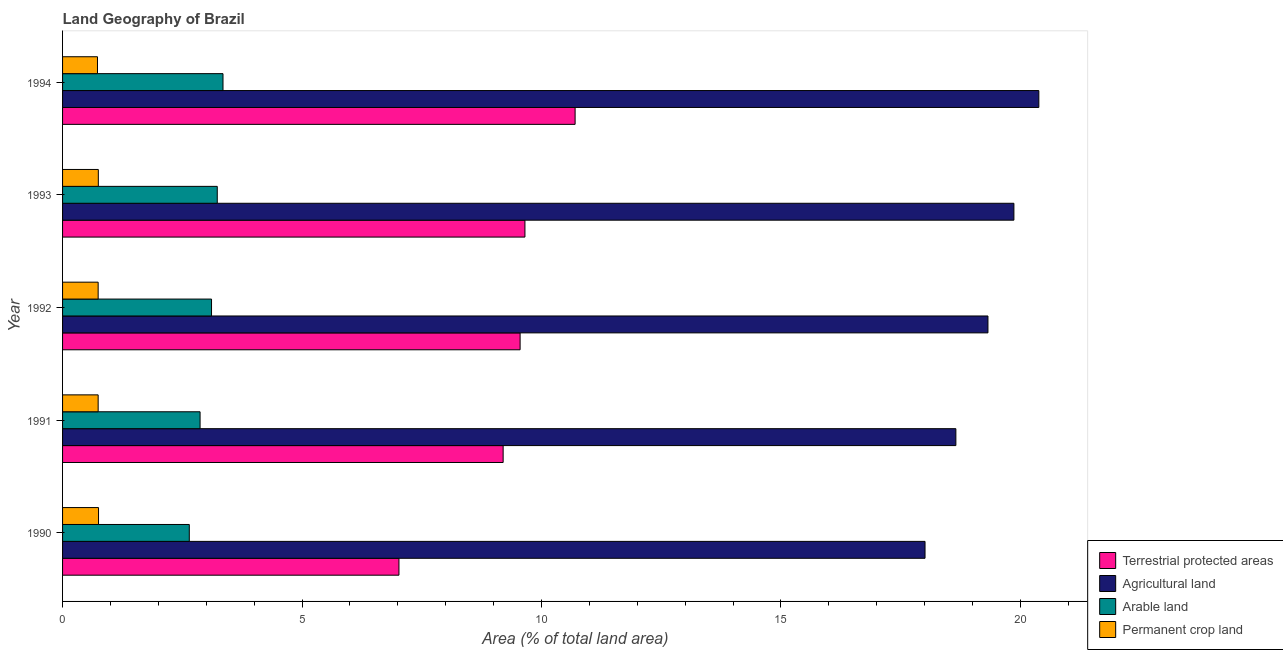Are the number of bars on each tick of the Y-axis equal?
Your response must be concise. Yes. How many bars are there on the 3rd tick from the top?
Your response must be concise. 4. In how many cases, is the number of bars for a given year not equal to the number of legend labels?
Keep it short and to the point. 0. What is the percentage of area under permanent crop land in 1991?
Provide a short and direct response. 0.74. Across all years, what is the maximum percentage of land under terrestrial protection?
Offer a very short reply. 10.7. Across all years, what is the minimum percentage of area under permanent crop land?
Your answer should be compact. 0.73. In which year was the percentage of area under arable land maximum?
Your response must be concise. 1994. What is the total percentage of area under agricultural land in the graph?
Your answer should be very brief. 96.24. What is the difference between the percentage of land under terrestrial protection in 1991 and that in 1993?
Your response must be concise. -0.46. What is the difference between the percentage of area under agricultural land in 1991 and the percentage of land under terrestrial protection in 1992?
Ensure brevity in your answer.  9.1. What is the average percentage of area under arable land per year?
Keep it short and to the point. 3.04. In the year 1990, what is the difference between the percentage of area under permanent crop land and percentage of land under terrestrial protection?
Give a very brief answer. -6.27. What is the ratio of the percentage of area under arable land in 1990 to that in 1991?
Your answer should be compact. 0.92. Is the percentage of area under permanent crop land in 1991 less than that in 1993?
Your answer should be compact. Yes. What is the difference between the highest and the second highest percentage of area under agricultural land?
Keep it short and to the point. 0.52. What is the difference between the highest and the lowest percentage of area under permanent crop land?
Your answer should be very brief. 0.02. In how many years, is the percentage of area under arable land greater than the average percentage of area under arable land taken over all years?
Provide a short and direct response. 3. Is the sum of the percentage of area under agricultural land in 1991 and 1992 greater than the maximum percentage of area under permanent crop land across all years?
Your answer should be compact. Yes. Is it the case that in every year, the sum of the percentage of area under permanent crop land and percentage of area under agricultural land is greater than the sum of percentage of area under arable land and percentage of land under terrestrial protection?
Your response must be concise. Yes. What does the 1st bar from the top in 1994 represents?
Provide a short and direct response. Permanent crop land. What does the 4th bar from the bottom in 1993 represents?
Your answer should be very brief. Permanent crop land. How many bars are there?
Offer a terse response. 20. Are all the bars in the graph horizontal?
Your answer should be very brief. Yes. How many years are there in the graph?
Offer a terse response. 5. Where does the legend appear in the graph?
Give a very brief answer. Bottom right. How many legend labels are there?
Offer a very short reply. 4. What is the title of the graph?
Ensure brevity in your answer.  Land Geography of Brazil. What is the label or title of the X-axis?
Ensure brevity in your answer.  Area (% of total land area). What is the label or title of the Y-axis?
Your answer should be compact. Year. What is the Area (% of total land area) of Terrestrial protected areas in 1990?
Give a very brief answer. 7.02. What is the Area (% of total land area) of Agricultural land in 1990?
Provide a succinct answer. 18.01. What is the Area (% of total land area) of Arable land in 1990?
Your response must be concise. 2.65. What is the Area (% of total land area) of Permanent crop land in 1990?
Make the answer very short. 0.75. What is the Area (% of total land area) in Terrestrial protected areas in 1991?
Offer a very short reply. 9.2. What is the Area (% of total land area) of Agricultural land in 1991?
Offer a terse response. 18.65. What is the Area (% of total land area) of Arable land in 1991?
Offer a very short reply. 2.87. What is the Area (% of total land area) of Permanent crop land in 1991?
Ensure brevity in your answer.  0.74. What is the Area (% of total land area) in Terrestrial protected areas in 1992?
Give a very brief answer. 9.55. What is the Area (% of total land area) in Agricultural land in 1992?
Your answer should be very brief. 19.32. What is the Area (% of total land area) of Arable land in 1992?
Give a very brief answer. 3.11. What is the Area (% of total land area) in Permanent crop land in 1992?
Offer a terse response. 0.74. What is the Area (% of total land area) in Terrestrial protected areas in 1993?
Your answer should be very brief. 9.66. What is the Area (% of total land area) in Agricultural land in 1993?
Offer a very short reply. 19.87. What is the Area (% of total land area) in Arable land in 1993?
Ensure brevity in your answer.  3.23. What is the Area (% of total land area) in Permanent crop land in 1993?
Make the answer very short. 0.75. What is the Area (% of total land area) in Terrestrial protected areas in 1994?
Your answer should be very brief. 10.7. What is the Area (% of total land area) of Agricultural land in 1994?
Your answer should be very brief. 20.39. What is the Area (% of total land area) in Arable land in 1994?
Offer a very short reply. 3.35. What is the Area (% of total land area) in Permanent crop land in 1994?
Your answer should be compact. 0.73. Across all years, what is the maximum Area (% of total land area) of Terrestrial protected areas?
Your answer should be very brief. 10.7. Across all years, what is the maximum Area (% of total land area) of Agricultural land?
Offer a very short reply. 20.39. Across all years, what is the maximum Area (% of total land area) of Arable land?
Make the answer very short. 3.35. Across all years, what is the maximum Area (% of total land area) in Permanent crop land?
Your response must be concise. 0.75. Across all years, what is the minimum Area (% of total land area) in Terrestrial protected areas?
Keep it short and to the point. 7.02. Across all years, what is the minimum Area (% of total land area) in Agricultural land?
Keep it short and to the point. 18.01. Across all years, what is the minimum Area (% of total land area) of Arable land?
Your answer should be compact. 2.65. Across all years, what is the minimum Area (% of total land area) of Permanent crop land?
Provide a succinct answer. 0.73. What is the total Area (% of total land area) in Terrestrial protected areas in the graph?
Ensure brevity in your answer.  46.14. What is the total Area (% of total land area) of Agricultural land in the graph?
Provide a short and direct response. 96.24. What is the total Area (% of total land area) of Arable land in the graph?
Ensure brevity in your answer.  15.21. What is the total Area (% of total land area) in Permanent crop land in the graph?
Your response must be concise. 3.71. What is the difference between the Area (% of total land area) of Terrestrial protected areas in 1990 and that in 1991?
Make the answer very short. -2.18. What is the difference between the Area (% of total land area) of Agricultural land in 1990 and that in 1991?
Your answer should be compact. -0.64. What is the difference between the Area (% of total land area) of Arable land in 1990 and that in 1991?
Your answer should be very brief. -0.23. What is the difference between the Area (% of total land area) of Permanent crop land in 1990 and that in 1991?
Your answer should be very brief. 0.01. What is the difference between the Area (% of total land area) of Terrestrial protected areas in 1990 and that in 1992?
Give a very brief answer. -2.53. What is the difference between the Area (% of total land area) of Agricultural land in 1990 and that in 1992?
Make the answer very short. -1.31. What is the difference between the Area (% of total land area) of Arable land in 1990 and that in 1992?
Offer a terse response. -0.46. What is the difference between the Area (% of total land area) of Permanent crop land in 1990 and that in 1992?
Provide a succinct answer. 0.01. What is the difference between the Area (% of total land area) of Terrestrial protected areas in 1990 and that in 1993?
Keep it short and to the point. -2.63. What is the difference between the Area (% of total land area) in Agricultural land in 1990 and that in 1993?
Offer a very short reply. -1.86. What is the difference between the Area (% of total land area) of Arable land in 1990 and that in 1993?
Provide a succinct answer. -0.58. What is the difference between the Area (% of total land area) of Permanent crop land in 1990 and that in 1993?
Your response must be concise. 0. What is the difference between the Area (% of total land area) of Terrestrial protected areas in 1990 and that in 1994?
Ensure brevity in your answer.  -3.68. What is the difference between the Area (% of total land area) of Agricultural land in 1990 and that in 1994?
Your answer should be very brief. -2.38. What is the difference between the Area (% of total land area) of Arable land in 1990 and that in 1994?
Ensure brevity in your answer.  -0.7. What is the difference between the Area (% of total land area) in Permanent crop land in 1990 and that in 1994?
Your answer should be very brief. 0.02. What is the difference between the Area (% of total land area) of Terrestrial protected areas in 1991 and that in 1992?
Your answer should be very brief. -0.35. What is the difference between the Area (% of total land area) of Agricultural land in 1991 and that in 1992?
Your answer should be very brief. -0.67. What is the difference between the Area (% of total land area) of Arable land in 1991 and that in 1992?
Your answer should be compact. -0.24. What is the difference between the Area (% of total land area) of Terrestrial protected areas in 1991 and that in 1993?
Keep it short and to the point. -0.46. What is the difference between the Area (% of total land area) in Agricultural land in 1991 and that in 1993?
Offer a terse response. -1.21. What is the difference between the Area (% of total land area) in Arable land in 1991 and that in 1993?
Make the answer very short. -0.36. What is the difference between the Area (% of total land area) in Permanent crop land in 1991 and that in 1993?
Your response must be concise. -0. What is the difference between the Area (% of total land area) of Terrestrial protected areas in 1991 and that in 1994?
Offer a very short reply. -1.5. What is the difference between the Area (% of total land area) of Agricultural land in 1991 and that in 1994?
Your answer should be very brief. -1.73. What is the difference between the Area (% of total land area) of Arable land in 1991 and that in 1994?
Your answer should be compact. -0.48. What is the difference between the Area (% of total land area) in Permanent crop land in 1991 and that in 1994?
Keep it short and to the point. 0.01. What is the difference between the Area (% of total land area) in Terrestrial protected areas in 1992 and that in 1993?
Give a very brief answer. -0.1. What is the difference between the Area (% of total land area) of Agricultural land in 1992 and that in 1993?
Ensure brevity in your answer.  -0.54. What is the difference between the Area (% of total land area) in Arable land in 1992 and that in 1993?
Provide a short and direct response. -0.12. What is the difference between the Area (% of total land area) in Permanent crop land in 1992 and that in 1993?
Your response must be concise. -0. What is the difference between the Area (% of total land area) in Terrestrial protected areas in 1992 and that in 1994?
Provide a succinct answer. -1.15. What is the difference between the Area (% of total land area) of Agricultural land in 1992 and that in 1994?
Offer a very short reply. -1.06. What is the difference between the Area (% of total land area) of Arable land in 1992 and that in 1994?
Your answer should be compact. -0.24. What is the difference between the Area (% of total land area) in Permanent crop land in 1992 and that in 1994?
Your answer should be compact. 0.01. What is the difference between the Area (% of total land area) of Terrestrial protected areas in 1993 and that in 1994?
Offer a very short reply. -1.05. What is the difference between the Area (% of total land area) in Agricultural land in 1993 and that in 1994?
Your answer should be compact. -0.52. What is the difference between the Area (% of total land area) of Arable land in 1993 and that in 1994?
Ensure brevity in your answer.  -0.12. What is the difference between the Area (% of total land area) in Permanent crop land in 1993 and that in 1994?
Offer a terse response. 0.02. What is the difference between the Area (% of total land area) of Terrestrial protected areas in 1990 and the Area (% of total land area) of Agricultural land in 1991?
Provide a short and direct response. -11.63. What is the difference between the Area (% of total land area) of Terrestrial protected areas in 1990 and the Area (% of total land area) of Arable land in 1991?
Your answer should be compact. 4.15. What is the difference between the Area (% of total land area) of Terrestrial protected areas in 1990 and the Area (% of total land area) of Permanent crop land in 1991?
Your response must be concise. 6.28. What is the difference between the Area (% of total land area) of Agricultural land in 1990 and the Area (% of total land area) of Arable land in 1991?
Your answer should be very brief. 15.14. What is the difference between the Area (% of total land area) of Agricultural land in 1990 and the Area (% of total land area) of Permanent crop land in 1991?
Provide a short and direct response. 17.27. What is the difference between the Area (% of total land area) in Arable land in 1990 and the Area (% of total land area) in Permanent crop land in 1991?
Ensure brevity in your answer.  1.9. What is the difference between the Area (% of total land area) in Terrestrial protected areas in 1990 and the Area (% of total land area) in Agricultural land in 1992?
Offer a very short reply. -12.3. What is the difference between the Area (% of total land area) of Terrestrial protected areas in 1990 and the Area (% of total land area) of Arable land in 1992?
Offer a very short reply. 3.91. What is the difference between the Area (% of total land area) in Terrestrial protected areas in 1990 and the Area (% of total land area) in Permanent crop land in 1992?
Your response must be concise. 6.28. What is the difference between the Area (% of total land area) in Agricultural land in 1990 and the Area (% of total land area) in Arable land in 1992?
Provide a succinct answer. 14.9. What is the difference between the Area (% of total land area) of Agricultural land in 1990 and the Area (% of total land area) of Permanent crop land in 1992?
Offer a very short reply. 17.27. What is the difference between the Area (% of total land area) of Arable land in 1990 and the Area (% of total land area) of Permanent crop land in 1992?
Offer a terse response. 1.9. What is the difference between the Area (% of total land area) in Terrestrial protected areas in 1990 and the Area (% of total land area) in Agricultural land in 1993?
Your answer should be compact. -12.84. What is the difference between the Area (% of total land area) of Terrestrial protected areas in 1990 and the Area (% of total land area) of Arable land in 1993?
Make the answer very short. 3.79. What is the difference between the Area (% of total land area) in Terrestrial protected areas in 1990 and the Area (% of total land area) in Permanent crop land in 1993?
Give a very brief answer. 6.28. What is the difference between the Area (% of total land area) in Agricultural land in 1990 and the Area (% of total land area) in Arable land in 1993?
Give a very brief answer. 14.78. What is the difference between the Area (% of total land area) of Agricultural land in 1990 and the Area (% of total land area) of Permanent crop land in 1993?
Your answer should be very brief. 17.26. What is the difference between the Area (% of total land area) in Arable land in 1990 and the Area (% of total land area) in Permanent crop land in 1993?
Your answer should be very brief. 1.9. What is the difference between the Area (% of total land area) of Terrestrial protected areas in 1990 and the Area (% of total land area) of Agricultural land in 1994?
Provide a short and direct response. -13.36. What is the difference between the Area (% of total land area) of Terrestrial protected areas in 1990 and the Area (% of total land area) of Arable land in 1994?
Provide a short and direct response. 3.67. What is the difference between the Area (% of total land area) of Terrestrial protected areas in 1990 and the Area (% of total land area) of Permanent crop land in 1994?
Provide a succinct answer. 6.3. What is the difference between the Area (% of total land area) in Agricultural land in 1990 and the Area (% of total land area) in Arable land in 1994?
Offer a very short reply. 14.66. What is the difference between the Area (% of total land area) in Agricultural land in 1990 and the Area (% of total land area) in Permanent crop land in 1994?
Provide a succinct answer. 17.28. What is the difference between the Area (% of total land area) in Arable land in 1990 and the Area (% of total land area) in Permanent crop land in 1994?
Ensure brevity in your answer.  1.92. What is the difference between the Area (% of total land area) of Terrestrial protected areas in 1991 and the Area (% of total land area) of Agricultural land in 1992?
Your answer should be compact. -10.12. What is the difference between the Area (% of total land area) in Terrestrial protected areas in 1991 and the Area (% of total land area) in Arable land in 1992?
Your answer should be very brief. 6.09. What is the difference between the Area (% of total land area) of Terrestrial protected areas in 1991 and the Area (% of total land area) of Permanent crop land in 1992?
Keep it short and to the point. 8.46. What is the difference between the Area (% of total land area) in Agricultural land in 1991 and the Area (% of total land area) in Arable land in 1992?
Offer a terse response. 15.54. What is the difference between the Area (% of total land area) in Agricultural land in 1991 and the Area (% of total land area) in Permanent crop land in 1992?
Make the answer very short. 17.91. What is the difference between the Area (% of total land area) in Arable land in 1991 and the Area (% of total land area) in Permanent crop land in 1992?
Your response must be concise. 2.13. What is the difference between the Area (% of total land area) in Terrestrial protected areas in 1991 and the Area (% of total land area) in Agricultural land in 1993?
Give a very brief answer. -10.67. What is the difference between the Area (% of total land area) of Terrestrial protected areas in 1991 and the Area (% of total land area) of Arable land in 1993?
Your answer should be compact. 5.97. What is the difference between the Area (% of total land area) in Terrestrial protected areas in 1991 and the Area (% of total land area) in Permanent crop land in 1993?
Give a very brief answer. 8.45. What is the difference between the Area (% of total land area) of Agricultural land in 1991 and the Area (% of total land area) of Arable land in 1993?
Provide a short and direct response. 15.42. What is the difference between the Area (% of total land area) in Agricultural land in 1991 and the Area (% of total land area) in Permanent crop land in 1993?
Provide a short and direct response. 17.91. What is the difference between the Area (% of total land area) of Arable land in 1991 and the Area (% of total land area) of Permanent crop land in 1993?
Keep it short and to the point. 2.12. What is the difference between the Area (% of total land area) of Terrestrial protected areas in 1991 and the Area (% of total land area) of Agricultural land in 1994?
Keep it short and to the point. -11.19. What is the difference between the Area (% of total land area) of Terrestrial protected areas in 1991 and the Area (% of total land area) of Arable land in 1994?
Your answer should be compact. 5.85. What is the difference between the Area (% of total land area) of Terrestrial protected areas in 1991 and the Area (% of total land area) of Permanent crop land in 1994?
Your response must be concise. 8.47. What is the difference between the Area (% of total land area) in Agricultural land in 1991 and the Area (% of total land area) in Arable land in 1994?
Your answer should be very brief. 15.3. What is the difference between the Area (% of total land area) in Agricultural land in 1991 and the Area (% of total land area) in Permanent crop land in 1994?
Your response must be concise. 17.92. What is the difference between the Area (% of total land area) of Arable land in 1991 and the Area (% of total land area) of Permanent crop land in 1994?
Keep it short and to the point. 2.14. What is the difference between the Area (% of total land area) in Terrestrial protected areas in 1992 and the Area (% of total land area) in Agricultural land in 1993?
Offer a terse response. -10.31. What is the difference between the Area (% of total land area) in Terrestrial protected areas in 1992 and the Area (% of total land area) in Arable land in 1993?
Your response must be concise. 6.32. What is the difference between the Area (% of total land area) of Terrestrial protected areas in 1992 and the Area (% of total land area) of Permanent crop land in 1993?
Make the answer very short. 8.81. What is the difference between the Area (% of total land area) in Agricultural land in 1992 and the Area (% of total land area) in Arable land in 1993?
Your response must be concise. 16.09. What is the difference between the Area (% of total land area) of Agricultural land in 1992 and the Area (% of total land area) of Permanent crop land in 1993?
Offer a very short reply. 18.58. What is the difference between the Area (% of total land area) in Arable land in 1992 and the Area (% of total land area) in Permanent crop land in 1993?
Your response must be concise. 2.36. What is the difference between the Area (% of total land area) of Terrestrial protected areas in 1992 and the Area (% of total land area) of Agricultural land in 1994?
Keep it short and to the point. -10.83. What is the difference between the Area (% of total land area) of Terrestrial protected areas in 1992 and the Area (% of total land area) of Arable land in 1994?
Give a very brief answer. 6.2. What is the difference between the Area (% of total land area) of Terrestrial protected areas in 1992 and the Area (% of total land area) of Permanent crop land in 1994?
Provide a short and direct response. 8.82. What is the difference between the Area (% of total land area) of Agricultural land in 1992 and the Area (% of total land area) of Arable land in 1994?
Offer a terse response. 15.97. What is the difference between the Area (% of total land area) of Agricultural land in 1992 and the Area (% of total land area) of Permanent crop land in 1994?
Your answer should be very brief. 18.59. What is the difference between the Area (% of total land area) of Arable land in 1992 and the Area (% of total land area) of Permanent crop land in 1994?
Ensure brevity in your answer.  2.38. What is the difference between the Area (% of total land area) in Terrestrial protected areas in 1993 and the Area (% of total land area) in Agricultural land in 1994?
Make the answer very short. -10.73. What is the difference between the Area (% of total land area) in Terrestrial protected areas in 1993 and the Area (% of total land area) in Arable land in 1994?
Your response must be concise. 6.31. What is the difference between the Area (% of total land area) in Terrestrial protected areas in 1993 and the Area (% of total land area) in Permanent crop land in 1994?
Your response must be concise. 8.93. What is the difference between the Area (% of total land area) in Agricultural land in 1993 and the Area (% of total land area) in Arable land in 1994?
Ensure brevity in your answer.  16.52. What is the difference between the Area (% of total land area) in Agricultural land in 1993 and the Area (% of total land area) in Permanent crop land in 1994?
Ensure brevity in your answer.  19.14. What is the difference between the Area (% of total land area) in Arable land in 1993 and the Area (% of total land area) in Permanent crop land in 1994?
Your response must be concise. 2.5. What is the average Area (% of total land area) in Terrestrial protected areas per year?
Give a very brief answer. 9.23. What is the average Area (% of total land area) in Agricultural land per year?
Your response must be concise. 19.25. What is the average Area (% of total land area) in Arable land per year?
Your answer should be compact. 3.04. What is the average Area (% of total land area) of Permanent crop land per year?
Offer a very short reply. 0.74. In the year 1990, what is the difference between the Area (% of total land area) in Terrestrial protected areas and Area (% of total land area) in Agricultural land?
Offer a very short reply. -10.99. In the year 1990, what is the difference between the Area (% of total land area) in Terrestrial protected areas and Area (% of total land area) in Arable land?
Make the answer very short. 4.38. In the year 1990, what is the difference between the Area (% of total land area) in Terrestrial protected areas and Area (% of total land area) in Permanent crop land?
Give a very brief answer. 6.27. In the year 1990, what is the difference between the Area (% of total land area) of Agricultural land and Area (% of total land area) of Arable land?
Your answer should be compact. 15.36. In the year 1990, what is the difference between the Area (% of total land area) of Agricultural land and Area (% of total land area) of Permanent crop land?
Your answer should be compact. 17.26. In the year 1990, what is the difference between the Area (% of total land area) of Arable land and Area (% of total land area) of Permanent crop land?
Offer a very short reply. 1.9. In the year 1991, what is the difference between the Area (% of total land area) in Terrestrial protected areas and Area (% of total land area) in Agricultural land?
Provide a short and direct response. -9.45. In the year 1991, what is the difference between the Area (% of total land area) in Terrestrial protected areas and Area (% of total land area) in Arable land?
Provide a short and direct response. 6.33. In the year 1991, what is the difference between the Area (% of total land area) in Terrestrial protected areas and Area (% of total land area) in Permanent crop land?
Keep it short and to the point. 8.46. In the year 1991, what is the difference between the Area (% of total land area) of Agricultural land and Area (% of total land area) of Arable land?
Offer a very short reply. 15.78. In the year 1991, what is the difference between the Area (% of total land area) in Agricultural land and Area (% of total land area) in Permanent crop land?
Provide a short and direct response. 17.91. In the year 1991, what is the difference between the Area (% of total land area) in Arable land and Area (% of total land area) in Permanent crop land?
Your answer should be compact. 2.13. In the year 1992, what is the difference between the Area (% of total land area) in Terrestrial protected areas and Area (% of total land area) in Agricultural land?
Your answer should be very brief. -9.77. In the year 1992, what is the difference between the Area (% of total land area) of Terrestrial protected areas and Area (% of total land area) of Arable land?
Provide a succinct answer. 6.44. In the year 1992, what is the difference between the Area (% of total land area) in Terrestrial protected areas and Area (% of total land area) in Permanent crop land?
Ensure brevity in your answer.  8.81. In the year 1992, what is the difference between the Area (% of total land area) of Agricultural land and Area (% of total land area) of Arable land?
Make the answer very short. 16.21. In the year 1992, what is the difference between the Area (% of total land area) in Agricultural land and Area (% of total land area) in Permanent crop land?
Your answer should be compact. 18.58. In the year 1992, what is the difference between the Area (% of total land area) of Arable land and Area (% of total land area) of Permanent crop land?
Ensure brevity in your answer.  2.37. In the year 1993, what is the difference between the Area (% of total land area) of Terrestrial protected areas and Area (% of total land area) of Agricultural land?
Ensure brevity in your answer.  -10.21. In the year 1993, what is the difference between the Area (% of total land area) in Terrestrial protected areas and Area (% of total land area) in Arable land?
Make the answer very short. 6.42. In the year 1993, what is the difference between the Area (% of total land area) in Terrestrial protected areas and Area (% of total land area) in Permanent crop land?
Provide a short and direct response. 8.91. In the year 1993, what is the difference between the Area (% of total land area) of Agricultural land and Area (% of total land area) of Arable land?
Provide a succinct answer. 16.64. In the year 1993, what is the difference between the Area (% of total land area) in Agricultural land and Area (% of total land area) in Permanent crop land?
Provide a short and direct response. 19.12. In the year 1993, what is the difference between the Area (% of total land area) of Arable land and Area (% of total land area) of Permanent crop land?
Your answer should be very brief. 2.48. In the year 1994, what is the difference between the Area (% of total land area) of Terrestrial protected areas and Area (% of total land area) of Agricultural land?
Keep it short and to the point. -9.68. In the year 1994, what is the difference between the Area (% of total land area) in Terrestrial protected areas and Area (% of total land area) in Arable land?
Give a very brief answer. 7.35. In the year 1994, what is the difference between the Area (% of total land area) of Terrestrial protected areas and Area (% of total land area) of Permanent crop land?
Your answer should be compact. 9.97. In the year 1994, what is the difference between the Area (% of total land area) of Agricultural land and Area (% of total land area) of Arable land?
Your response must be concise. 17.04. In the year 1994, what is the difference between the Area (% of total land area) of Agricultural land and Area (% of total land area) of Permanent crop land?
Provide a short and direct response. 19.66. In the year 1994, what is the difference between the Area (% of total land area) in Arable land and Area (% of total land area) in Permanent crop land?
Your response must be concise. 2.62. What is the ratio of the Area (% of total land area) of Terrestrial protected areas in 1990 to that in 1991?
Provide a short and direct response. 0.76. What is the ratio of the Area (% of total land area) in Agricultural land in 1990 to that in 1991?
Offer a terse response. 0.97. What is the ratio of the Area (% of total land area) of Arable land in 1990 to that in 1991?
Keep it short and to the point. 0.92. What is the ratio of the Area (% of total land area) of Permanent crop land in 1990 to that in 1991?
Your answer should be compact. 1.01. What is the ratio of the Area (% of total land area) in Terrestrial protected areas in 1990 to that in 1992?
Make the answer very short. 0.74. What is the ratio of the Area (% of total land area) of Agricultural land in 1990 to that in 1992?
Ensure brevity in your answer.  0.93. What is the ratio of the Area (% of total land area) of Arable land in 1990 to that in 1992?
Provide a succinct answer. 0.85. What is the ratio of the Area (% of total land area) in Permanent crop land in 1990 to that in 1992?
Your answer should be compact. 1.01. What is the ratio of the Area (% of total land area) in Terrestrial protected areas in 1990 to that in 1993?
Give a very brief answer. 0.73. What is the ratio of the Area (% of total land area) in Agricultural land in 1990 to that in 1993?
Offer a very short reply. 0.91. What is the ratio of the Area (% of total land area) of Arable land in 1990 to that in 1993?
Offer a very short reply. 0.82. What is the ratio of the Area (% of total land area) in Permanent crop land in 1990 to that in 1993?
Your response must be concise. 1.01. What is the ratio of the Area (% of total land area) of Terrestrial protected areas in 1990 to that in 1994?
Offer a very short reply. 0.66. What is the ratio of the Area (% of total land area) in Agricultural land in 1990 to that in 1994?
Provide a short and direct response. 0.88. What is the ratio of the Area (% of total land area) of Arable land in 1990 to that in 1994?
Keep it short and to the point. 0.79. What is the ratio of the Area (% of total land area) in Permanent crop land in 1990 to that in 1994?
Provide a succinct answer. 1.03. What is the ratio of the Area (% of total land area) in Terrestrial protected areas in 1991 to that in 1992?
Make the answer very short. 0.96. What is the ratio of the Area (% of total land area) in Agricultural land in 1991 to that in 1992?
Your answer should be very brief. 0.97. What is the ratio of the Area (% of total land area) of Terrestrial protected areas in 1991 to that in 1993?
Ensure brevity in your answer.  0.95. What is the ratio of the Area (% of total land area) of Agricultural land in 1991 to that in 1993?
Offer a very short reply. 0.94. What is the ratio of the Area (% of total land area) of Permanent crop land in 1991 to that in 1993?
Make the answer very short. 1. What is the ratio of the Area (% of total land area) in Terrestrial protected areas in 1991 to that in 1994?
Ensure brevity in your answer.  0.86. What is the ratio of the Area (% of total land area) of Agricultural land in 1991 to that in 1994?
Provide a short and direct response. 0.92. What is the ratio of the Area (% of total land area) of Arable land in 1991 to that in 1994?
Provide a short and direct response. 0.86. What is the ratio of the Area (% of total land area) of Permanent crop land in 1991 to that in 1994?
Keep it short and to the point. 1.02. What is the ratio of the Area (% of total land area) in Agricultural land in 1992 to that in 1993?
Ensure brevity in your answer.  0.97. What is the ratio of the Area (% of total land area) of Terrestrial protected areas in 1992 to that in 1994?
Your response must be concise. 0.89. What is the ratio of the Area (% of total land area) of Agricultural land in 1992 to that in 1994?
Offer a terse response. 0.95. What is the ratio of the Area (% of total land area) of Arable land in 1992 to that in 1994?
Offer a terse response. 0.93. What is the ratio of the Area (% of total land area) of Permanent crop land in 1992 to that in 1994?
Offer a very short reply. 1.02. What is the ratio of the Area (% of total land area) in Terrestrial protected areas in 1993 to that in 1994?
Your answer should be compact. 0.9. What is the ratio of the Area (% of total land area) in Agricultural land in 1993 to that in 1994?
Your answer should be very brief. 0.97. What is the ratio of the Area (% of total land area) in Permanent crop land in 1993 to that in 1994?
Your answer should be very brief. 1.02. What is the difference between the highest and the second highest Area (% of total land area) in Terrestrial protected areas?
Your answer should be very brief. 1.05. What is the difference between the highest and the second highest Area (% of total land area) in Agricultural land?
Give a very brief answer. 0.52. What is the difference between the highest and the second highest Area (% of total land area) in Arable land?
Your response must be concise. 0.12. What is the difference between the highest and the second highest Area (% of total land area) of Permanent crop land?
Ensure brevity in your answer.  0. What is the difference between the highest and the lowest Area (% of total land area) of Terrestrial protected areas?
Keep it short and to the point. 3.68. What is the difference between the highest and the lowest Area (% of total land area) of Agricultural land?
Keep it short and to the point. 2.38. What is the difference between the highest and the lowest Area (% of total land area) in Arable land?
Your response must be concise. 0.7. What is the difference between the highest and the lowest Area (% of total land area) of Permanent crop land?
Give a very brief answer. 0.02. 